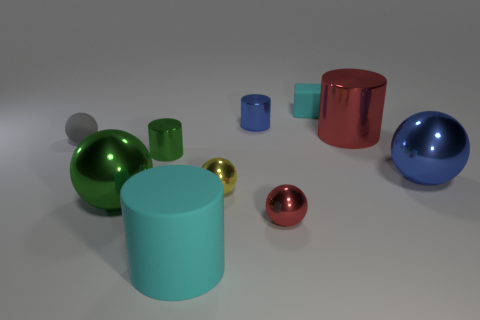There is a tiny metallic object left of the large rubber cylinder; is its shape the same as the cyan thing in front of the big blue thing? Indeed, upon closer inspection, the tiny metallic object to the left of the large rubber cylinder has the same spherical shape as the cyan object situated in front of the big blue spherical item. Both share the common geometrical properties of a sphere, characterized by a smooth, round surface where every point on the exterior is equidistant from the center. 